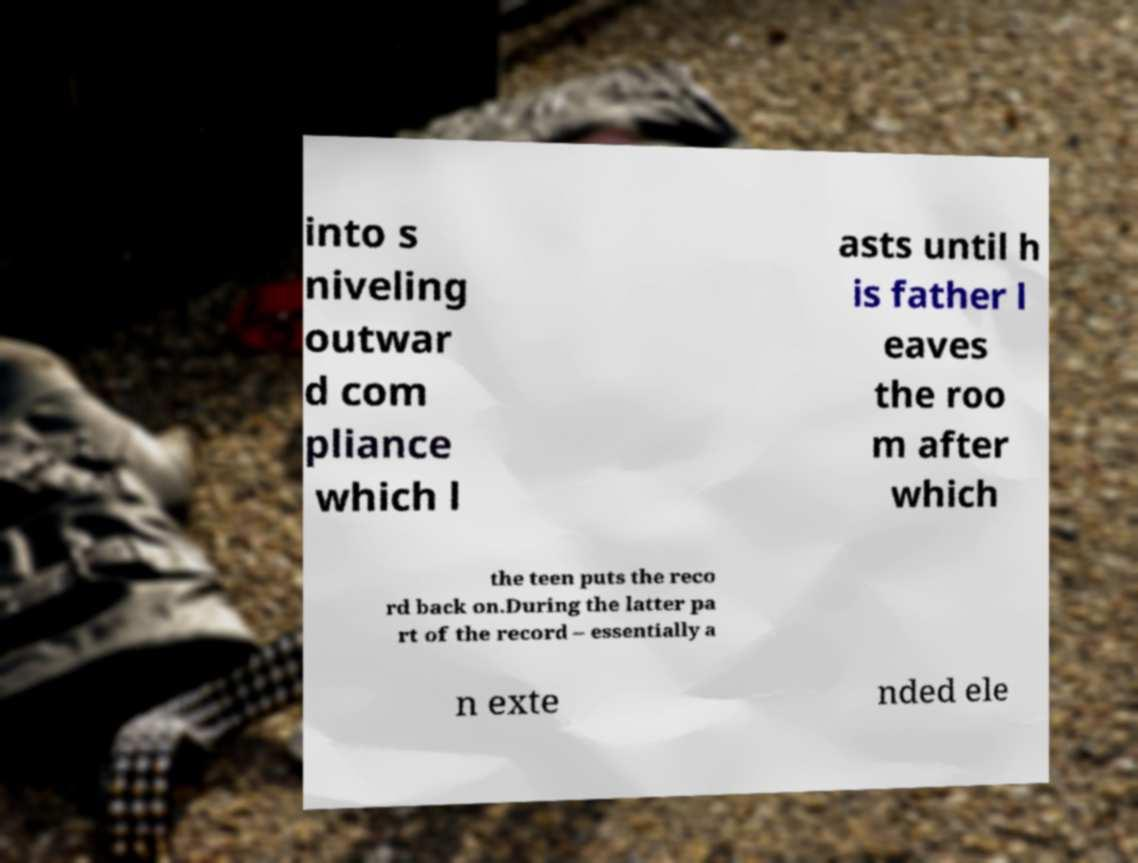Could you extract and type out the text from this image? into s niveling outwar d com pliance which l asts until h is father l eaves the roo m after which the teen puts the reco rd back on.During the latter pa rt of the record – essentially a n exte nded ele 